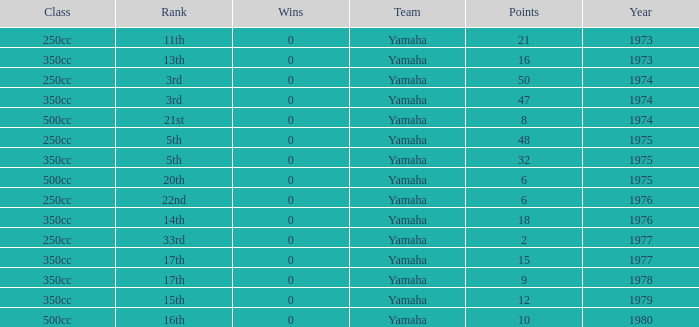Which Wins is the highest one that has a Class of 500cc, and Points smaller than 6? None. 